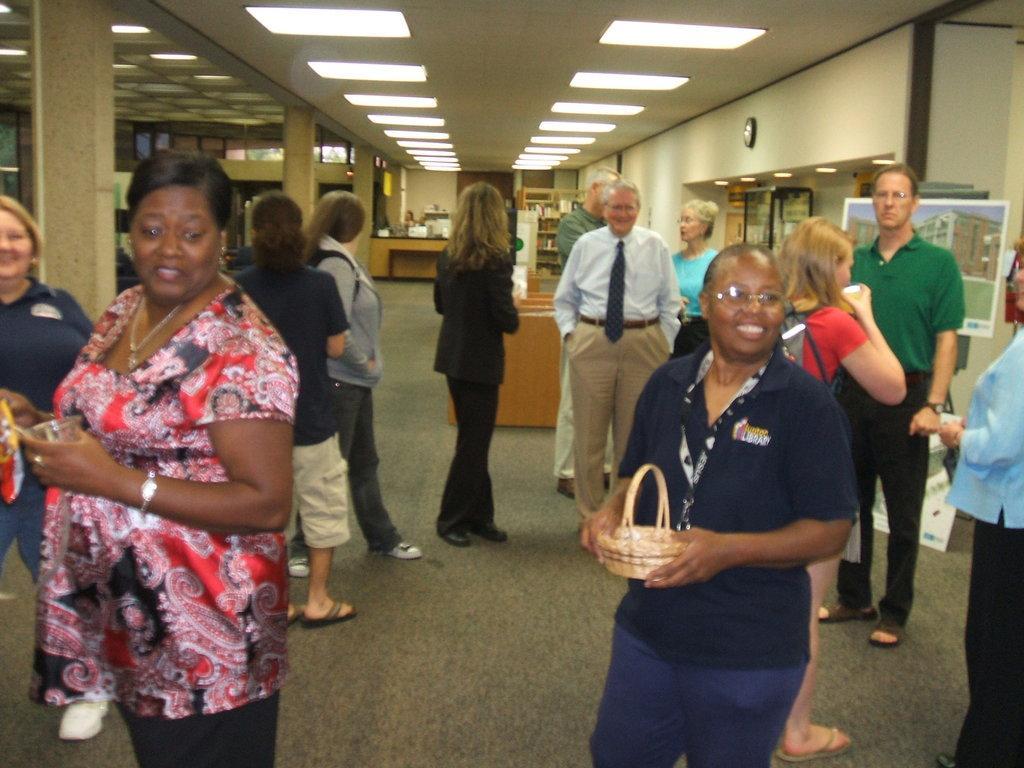In one or two sentences, can you explain what this image depicts? In this picture there are people on the right and left side of the image and there are lights at the top side of the image, it seems to be an office place. 